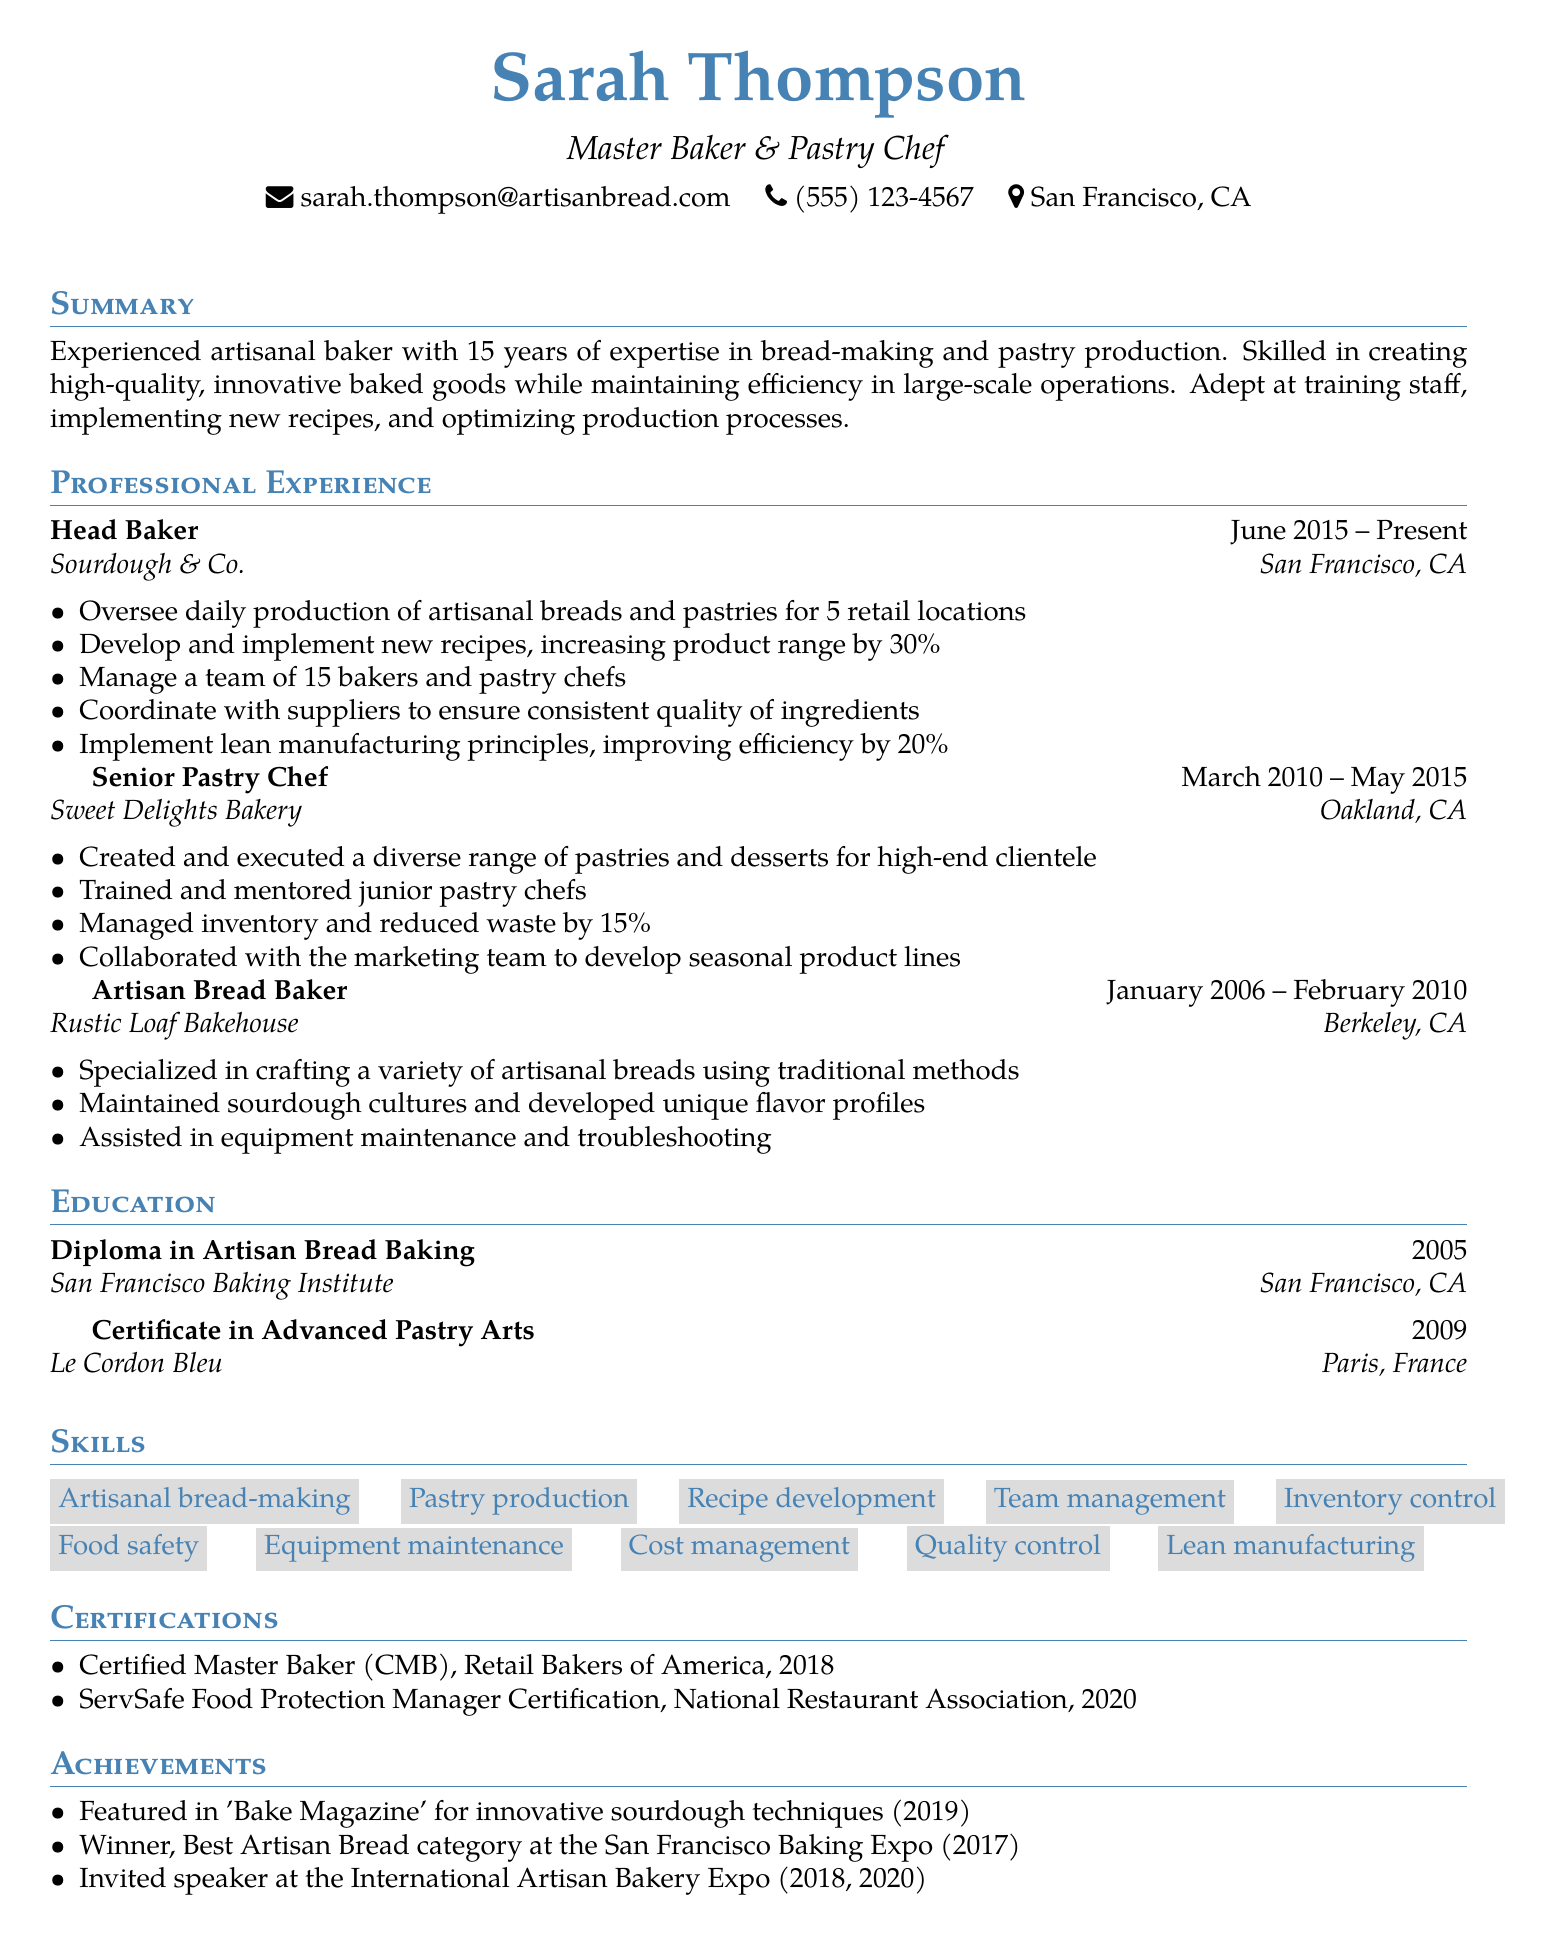What is the name of the individual? The name is located in the personal information section of the document.
Answer: Sarah Thompson What is the location of the current job? The job location is specified in the work experience section.
Answer: San Francisco, CA How many years of experience does the candidate have? The years of experience are mentioned in the summary of the document.
Answer: 15 years What position does Sarah currently hold? The current position is highlighted in the work experience section of the resume.
Answer: Head Baker What percentage did the product range increase by at Sourdough & Co.? This information is stated as a responsibility in the work experience section.
Answer: 30% What was the degree obtained from San Francisco Baking Institute? The degree information is listed in the education section.
Answer: Diploma in Artisan Bread Baking Which certification was obtained in 2020? This certification information is found in the certifications section of the document.
Answer: ServSafe Food Protection Manager Certification What is one of Sarah's achievements at the San Francisco Baking Expo? This is specified in the achievements section of the resume.
Answer: Winner, Best Artisan Bread category What skill involves managing a team? The skills related to team management are listed in the skills section of the document.
Answer: Team management 